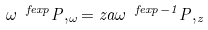<formula> <loc_0><loc_0><loc_500><loc_500>\omega ^ { \ f e x p } P , _ { \omega } = z a \omega ^ { \ f e x p - 1 } P , _ { z }</formula> 